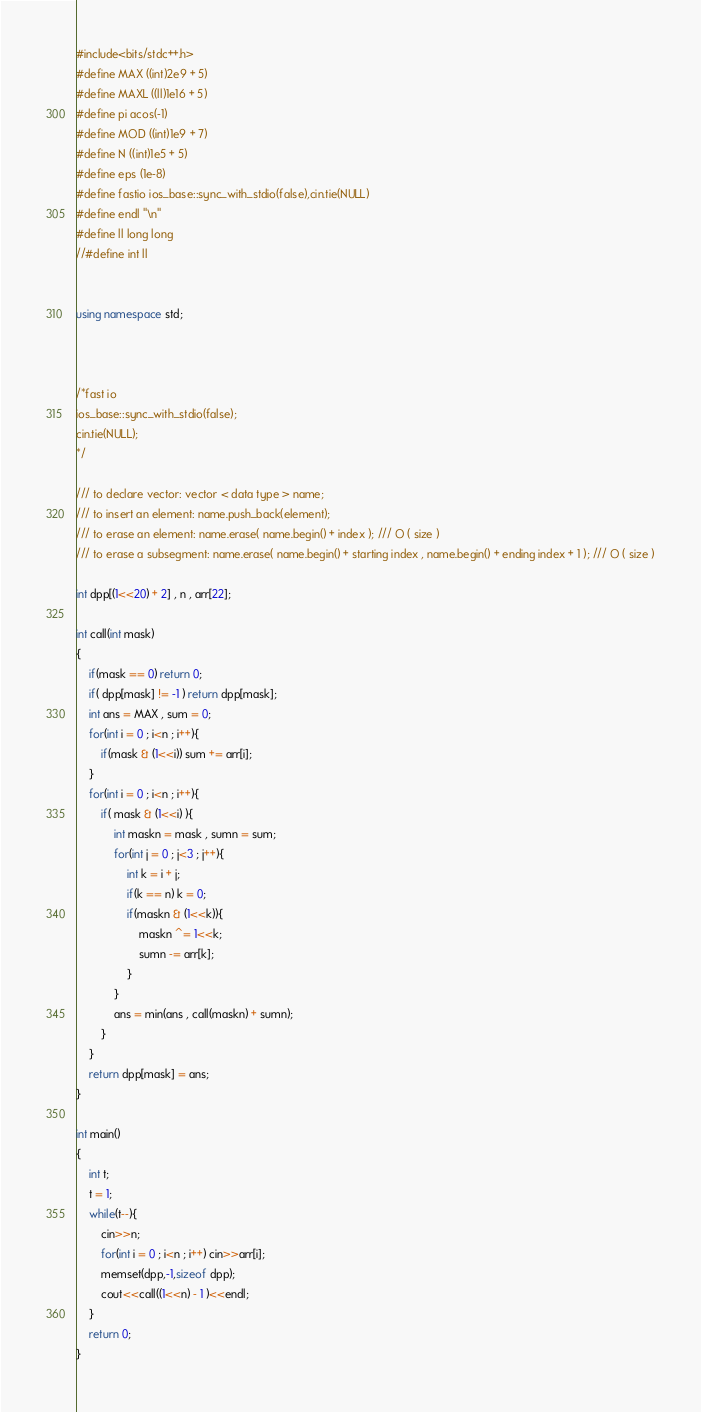<code> <loc_0><loc_0><loc_500><loc_500><_C++_>#include<bits/stdc++.h>
#define MAX ((int)2e9 + 5)
#define MAXL ((ll)1e16 + 5)
#define pi acos(-1)
#define MOD ((int)1e9 + 7)
#define N ((int)1e5 + 5)
#define eps (1e-8)
#define fastio ios_base::sync_with_stdio(false),cin.tie(NULL)
#define endl "\n"
#define ll long long
//#define int ll


using namespace std;



/*fast io
ios_base::sync_with_stdio(false);
cin.tie(NULL);
*/

/// to declare vector: vector < data type > name;
/// to insert an element: name.push_back(element);
/// to erase an element: name.erase( name.begin() + index ); /// O ( size )
/// to erase a subsegment: name.erase( name.begin() + starting index , name.begin() + ending index + 1 ); /// O ( size )

int dpp[(1<<20) + 2] , n , arr[22];

int call(int mask)
{
    if(mask == 0) return 0;
    if( dpp[mask] != -1 ) return dpp[mask];
    int ans = MAX , sum = 0;
    for(int i = 0 ; i<n ; i++){
        if(mask & (1<<i)) sum += arr[i];
    }
    for(int i = 0 ; i<n ; i++){
        if( mask & (1<<i) ){
            int maskn = mask , sumn = sum;
            for(int j = 0 ; j<3 ; j++){
                int k = i + j;
                if(k == n) k = 0;
                if(maskn & (1<<k)){
                    maskn ^= 1<<k;
                    sumn -= arr[k];
                }
            }
            ans = min(ans , call(maskn) + sumn);
        }
    }
    return dpp[mask] = ans;
}

int main()
{
    int t;
    t = 1;
    while(t--){
        cin>>n;
        for(int i = 0 ; i<n ; i++) cin>>arr[i];
        memset(dpp,-1,sizeof dpp);
        cout<<call((1<<n) - 1 )<<endl;
    }
    return 0;
}
</code> 